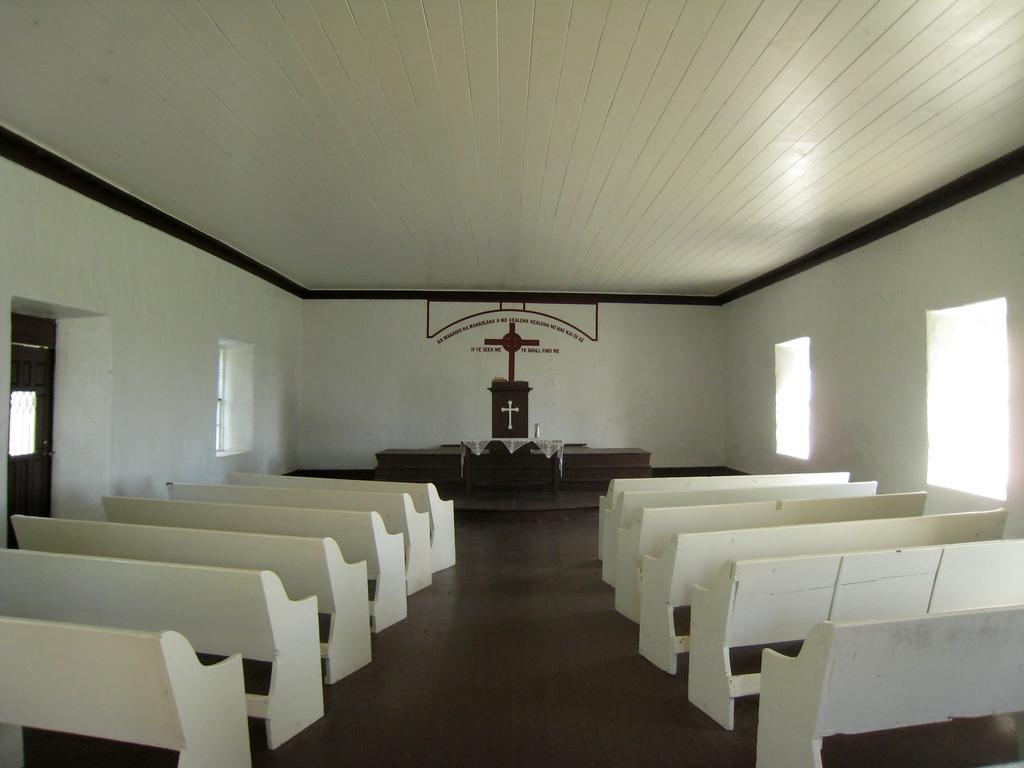In one or two sentences, can you explain what this image depicts? In this image I can see few windows and number of white color benches on the both side. In the background I can see a podium and on it I can see a cross sign. I can also see a cross sign on the wall and near it I can see something is written. On the left side of this image I can see a door. 